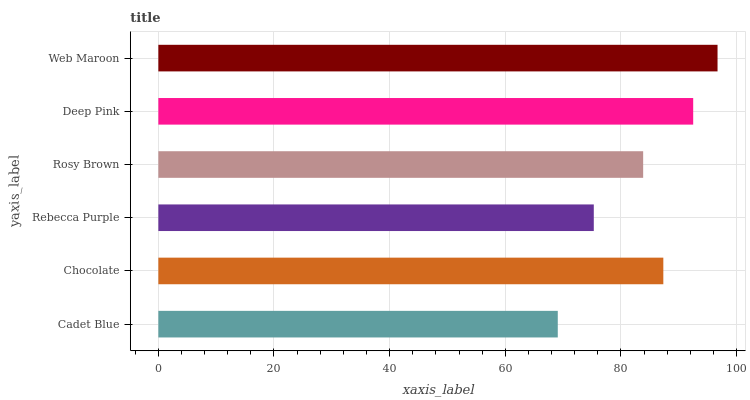Is Cadet Blue the minimum?
Answer yes or no. Yes. Is Web Maroon the maximum?
Answer yes or no. Yes. Is Chocolate the minimum?
Answer yes or no. No. Is Chocolate the maximum?
Answer yes or no. No. Is Chocolate greater than Cadet Blue?
Answer yes or no. Yes. Is Cadet Blue less than Chocolate?
Answer yes or no. Yes. Is Cadet Blue greater than Chocolate?
Answer yes or no. No. Is Chocolate less than Cadet Blue?
Answer yes or no. No. Is Chocolate the high median?
Answer yes or no. Yes. Is Rosy Brown the low median?
Answer yes or no. Yes. Is Rebecca Purple the high median?
Answer yes or no. No. Is Rebecca Purple the low median?
Answer yes or no. No. 